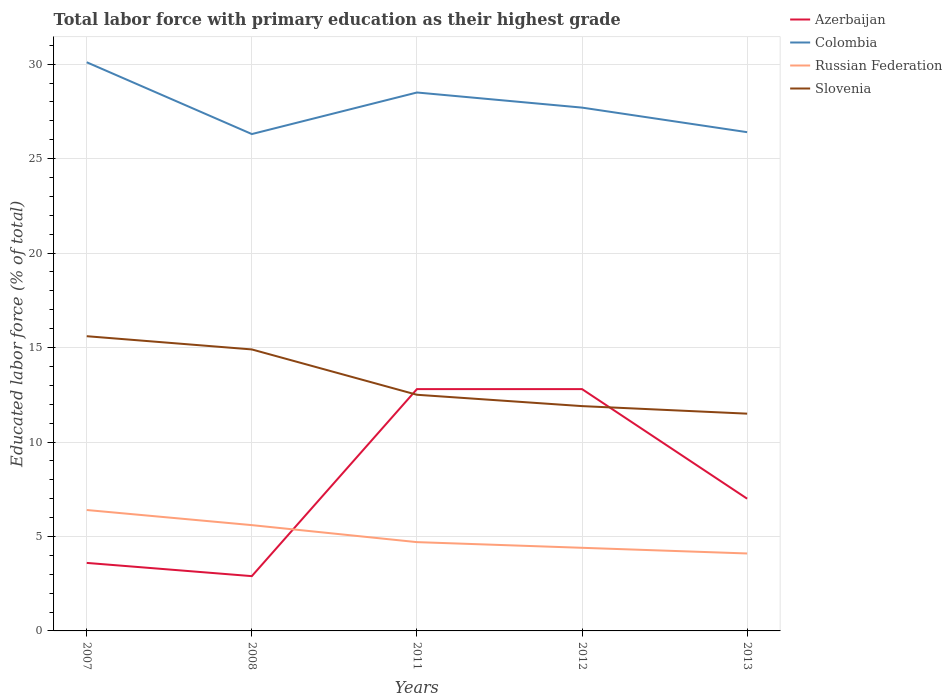Is the number of lines equal to the number of legend labels?
Ensure brevity in your answer.  Yes. Across all years, what is the maximum percentage of total labor force with primary education in Azerbaijan?
Provide a succinct answer. 2.9. In which year was the percentage of total labor force with primary education in Slovenia maximum?
Ensure brevity in your answer.  2013. What is the total percentage of total labor force with primary education in Russian Federation in the graph?
Provide a succinct answer. 1.5. What is the difference between the highest and the second highest percentage of total labor force with primary education in Slovenia?
Your answer should be compact. 4.1. Is the percentage of total labor force with primary education in Russian Federation strictly greater than the percentage of total labor force with primary education in Slovenia over the years?
Give a very brief answer. Yes. Does the graph contain any zero values?
Your response must be concise. No. Where does the legend appear in the graph?
Make the answer very short. Top right. How many legend labels are there?
Your response must be concise. 4. What is the title of the graph?
Provide a short and direct response. Total labor force with primary education as their highest grade. What is the label or title of the X-axis?
Your response must be concise. Years. What is the label or title of the Y-axis?
Provide a succinct answer. Educated labor force (% of total). What is the Educated labor force (% of total) in Azerbaijan in 2007?
Your answer should be compact. 3.6. What is the Educated labor force (% of total) of Colombia in 2007?
Provide a short and direct response. 30.1. What is the Educated labor force (% of total) in Russian Federation in 2007?
Keep it short and to the point. 6.4. What is the Educated labor force (% of total) in Slovenia in 2007?
Offer a terse response. 15.6. What is the Educated labor force (% of total) of Azerbaijan in 2008?
Make the answer very short. 2.9. What is the Educated labor force (% of total) in Colombia in 2008?
Your answer should be very brief. 26.3. What is the Educated labor force (% of total) of Russian Federation in 2008?
Make the answer very short. 5.6. What is the Educated labor force (% of total) in Slovenia in 2008?
Give a very brief answer. 14.9. What is the Educated labor force (% of total) of Azerbaijan in 2011?
Provide a succinct answer. 12.8. What is the Educated labor force (% of total) in Colombia in 2011?
Offer a very short reply. 28.5. What is the Educated labor force (% of total) of Russian Federation in 2011?
Ensure brevity in your answer.  4.7. What is the Educated labor force (% of total) of Slovenia in 2011?
Your answer should be very brief. 12.5. What is the Educated labor force (% of total) in Azerbaijan in 2012?
Give a very brief answer. 12.8. What is the Educated labor force (% of total) of Colombia in 2012?
Your answer should be very brief. 27.7. What is the Educated labor force (% of total) of Russian Federation in 2012?
Make the answer very short. 4.4. What is the Educated labor force (% of total) in Slovenia in 2012?
Give a very brief answer. 11.9. What is the Educated labor force (% of total) of Azerbaijan in 2013?
Provide a succinct answer. 7. What is the Educated labor force (% of total) in Colombia in 2013?
Offer a very short reply. 26.4. What is the Educated labor force (% of total) of Russian Federation in 2013?
Provide a succinct answer. 4.1. What is the Educated labor force (% of total) in Slovenia in 2013?
Provide a succinct answer. 11.5. Across all years, what is the maximum Educated labor force (% of total) in Azerbaijan?
Your answer should be compact. 12.8. Across all years, what is the maximum Educated labor force (% of total) of Colombia?
Your response must be concise. 30.1. Across all years, what is the maximum Educated labor force (% of total) of Russian Federation?
Offer a terse response. 6.4. Across all years, what is the maximum Educated labor force (% of total) of Slovenia?
Offer a very short reply. 15.6. Across all years, what is the minimum Educated labor force (% of total) in Azerbaijan?
Your answer should be very brief. 2.9. Across all years, what is the minimum Educated labor force (% of total) of Colombia?
Your answer should be very brief. 26.3. Across all years, what is the minimum Educated labor force (% of total) of Russian Federation?
Provide a succinct answer. 4.1. What is the total Educated labor force (% of total) of Azerbaijan in the graph?
Give a very brief answer. 39.1. What is the total Educated labor force (% of total) of Colombia in the graph?
Provide a short and direct response. 139. What is the total Educated labor force (% of total) of Russian Federation in the graph?
Keep it short and to the point. 25.2. What is the total Educated labor force (% of total) of Slovenia in the graph?
Your answer should be compact. 66.4. What is the difference between the Educated labor force (% of total) in Azerbaijan in 2007 and that in 2008?
Offer a very short reply. 0.7. What is the difference between the Educated labor force (% of total) of Colombia in 2007 and that in 2008?
Your response must be concise. 3.8. What is the difference between the Educated labor force (% of total) in Azerbaijan in 2007 and that in 2011?
Your answer should be very brief. -9.2. What is the difference between the Educated labor force (% of total) in Colombia in 2007 and that in 2012?
Give a very brief answer. 2.4. What is the difference between the Educated labor force (% of total) of Azerbaijan in 2007 and that in 2013?
Offer a terse response. -3.4. What is the difference between the Educated labor force (% of total) of Russian Federation in 2007 and that in 2013?
Keep it short and to the point. 2.3. What is the difference between the Educated labor force (% of total) in Azerbaijan in 2008 and that in 2011?
Give a very brief answer. -9.9. What is the difference between the Educated labor force (% of total) of Russian Federation in 2008 and that in 2011?
Give a very brief answer. 0.9. What is the difference between the Educated labor force (% of total) in Slovenia in 2008 and that in 2011?
Provide a short and direct response. 2.4. What is the difference between the Educated labor force (% of total) of Azerbaijan in 2008 and that in 2012?
Provide a succinct answer. -9.9. What is the difference between the Educated labor force (% of total) of Russian Federation in 2008 and that in 2012?
Provide a short and direct response. 1.2. What is the difference between the Educated labor force (% of total) of Slovenia in 2008 and that in 2012?
Provide a succinct answer. 3. What is the difference between the Educated labor force (% of total) in Azerbaijan in 2008 and that in 2013?
Your answer should be compact. -4.1. What is the difference between the Educated labor force (% of total) of Colombia in 2008 and that in 2013?
Your answer should be compact. -0.1. What is the difference between the Educated labor force (% of total) of Azerbaijan in 2011 and that in 2012?
Ensure brevity in your answer.  0. What is the difference between the Educated labor force (% of total) in Colombia in 2011 and that in 2013?
Your response must be concise. 2.1. What is the difference between the Educated labor force (% of total) of Russian Federation in 2011 and that in 2013?
Provide a succinct answer. 0.6. What is the difference between the Educated labor force (% of total) of Slovenia in 2011 and that in 2013?
Provide a succinct answer. 1. What is the difference between the Educated labor force (% of total) in Azerbaijan in 2012 and that in 2013?
Your answer should be compact. 5.8. What is the difference between the Educated labor force (% of total) of Colombia in 2012 and that in 2013?
Your answer should be very brief. 1.3. What is the difference between the Educated labor force (% of total) in Azerbaijan in 2007 and the Educated labor force (% of total) in Colombia in 2008?
Provide a short and direct response. -22.7. What is the difference between the Educated labor force (% of total) in Azerbaijan in 2007 and the Educated labor force (% of total) in Slovenia in 2008?
Your response must be concise. -11.3. What is the difference between the Educated labor force (% of total) of Colombia in 2007 and the Educated labor force (% of total) of Slovenia in 2008?
Your response must be concise. 15.2. What is the difference between the Educated labor force (% of total) in Azerbaijan in 2007 and the Educated labor force (% of total) in Colombia in 2011?
Keep it short and to the point. -24.9. What is the difference between the Educated labor force (% of total) in Azerbaijan in 2007 and the Educated labor force (% of total) in Russian Federation in 2011?
Give a very brief answer. -1.1. What is the difference between the Educated labor force (% of total) in Colombia in 2007 and the Educated labor force (% of total) in Russian Federation in 2011?
Provide a succinct answer. 25.4. What is the difference between the Educated labor force (% of total) of Colombia in 2007 and the Educated labor force (% of total) of Slovenia in 2011?
Provide a short and direct response. 17.6. What is the difference between the Educated labor force (% of total) in Azerbaijan in 2007 and the Educated labor force (% of total) in Colombia in 2012?
Provide a short and direct response. -24.1. What is the difference between the Educated labor force (% of total) in Azerbaijan in 2007 and the Educated labor force (% of total) in Russian Federation in 2012?
Offer a very short reply. -0.8. What is the difference between the Educated labor force (% of total) in Colombia in 2007 and the Educated labor force (% of total) in Russian Federation in 2012?
Provide a short and direct response. 25.7. What is the difference between the Educated labor force (% of total) of Colombia in 2007 and the Educated labor force (% of total) of Slovenia in 2012?
Your answer should be very brief. 18.2. What is the difference between the Educated labor force (% of total) in Azerbaijan in 2007 and the Educated labor force (% of total) in Colombia in 2013?
Provide a short and direct response. -22.8. What is the difference between the Educated labor force (% of total) of Azerbaijan in 2007 and the Educated labor force (% of total) of Russian Federation in 2013?
Provide a short and direct response. -0.5. What is the difference between the Educated labor force (% of total) in Azerbaijan in 2007 and the Educated labor force (% of total) in Slovenia in 2013?
Keep it short and to the point. -7.9. What is the difference between the Educated labor force (% of total) in Colombia in 2007 and the Educated labor force (% of total) in Slovenia in 2013?
Keep it short and to the point. 18.6. What is the difference between the Educated labor force (% of total) of Russian Federation in 2007 and the Educated labor force (% of total) of Slovenia in 2013?
Provide a short and direct response. -5.1. What is the difference between the Educated labor force (% of total) of Azerbaijan in 2008 and the Educated labor force (% of total) of Colombia in 2011?
Keep it short and to the point. -25.6. What is the difference between the Educated labor force (% of total) in Azerbaijan in 2008 and the Educated labor force (% of total) in Slovenia in 2011?
Keep it short and to the point. -9.6. What is the difference between the Educated labor force (% of total) of Colombia in 2008 and the Educated labor force (% of total) of Russian Federation in 2011?
Offer a very short reply. 21.6. What is the difference between the Educated labor force (% of total) in Azerbaijan in 2008 and the Educated labor force (% of total) in Colombia in 2012?
Offer a terse response. -24.8. What is the difference between the Educated labor force (% of total) in Colombia in 2008 and the Educated labor force (% of total) in Russian Federation in 2012?
Offer a terse response. 21.9. What is the difference between the Educated labor force (% of total) of Russian Federation in 2008 and the Educated labor force (% of total) of Slovenia in 2012?
Ensure brevity in your answer.  -6.3. What is the difference between the Educated labor force (% of total) of Azerbaijan in 2008 and the Educated labor force (% of total) of Colombia in 2013?
Ensure brevity in your answer.  -23.5. What is the difference between the Educated labor force (% of total) of Azerbaijan in 2008 and the Educated labor force (% of total) of Russian Federation in 2013?
Provide a succinct answer. -1.2. What is the difference between the Educated labor force (% of total) in Azerbaijan in 2008 and the Educated labor force (% of total) in Slovenia in 2013?
Keep it short and to the point. -8.6. What is the difference between the Educated labor force (% of total) in Colombia in 2008 and the Educated labor force (% of total) in Russian Federation in 2013?
Make the answer very short. 22.2. What is the difference between the Educated labor force (% of total) of Colombia in 2008 and the Educated labor force (% of total) of Slovenia in 2013?
Your answer should be very brief. 14.8. What is the difference between the Educated labor force (% of total) of Azerbaijan in 2011 and the Educated labor force (% of total) of Colombia in 2012?
Provide a succinct answer. -14.9. What is the difference between the Educated labor force (% of total) of Colombia in 2011 and the Educated labor force (% of total) of Russian Federation in 2012?
Ensure brevity in your answer.  24.1. What is the difference between the Educated labor force (% of total) of Azerbaijan in 2011 and the Educated labor force (% of total) of Slovenia in 2013?
Ensure brevity in your answer.  1.3. What is the difference between the Educated labor force (% of total) in Colombia in 2011 and the Educated labor force (% of total) in Russian Federation in 2013?
Give a very brief answer. 24.4. What is the difference between the Educated labor force (% of total) in Azerbaijan in 2012 and the Educated labor force (% of total) in Colombia in 2013?
Offer a terse response. -13.6. What is the difference between the Educated labor force (% of total) in Azerbaijan in 2012 and the Educated labor force (% of total) in Slovenia in 2013?
Your answer should be compact. 1.3. What is the difference between the Educated labor force (% of total) in Colombia in 2012 and the Educated labor force (% of total) in Russian Federation in 2013?
Provide a short and direct response. 23.6. What is the average Educated labor force (% of total) of Azerbaijan per year?
Provide a short and direct response. 7.82. What is the average Educated labor force (% of total) in Colombia per year?
Provide a short and direct response. 27.8. What is the average Educated labor force (% of total) in Russian Federation per year?
Offer a very short reply. 5.04. What is the average Educated labor force (% of total) in Slovenia per year?
Your answer should be very brief. 13.28. In the year 2007, what is the difference between the Educated labor force (% of total) in Azerbaijan and Educated labor force (% of total) in Colombia?
Ensure brevity in your answer.  -26.5. In the year 2007, what is the difference between the Educated labor force (% of total) of Azerbaijan and Educated labor force (% of total) of Russian Federation?
Provide a succinct answer. -2.8. In the year 2007, what is the difference between the Educated labor force (% of total) of Colombia and Educated labor force (% of total) of Russian Federation?
Offer a very short reply. 23.7. In the year 2007, what is the difference between the Educated labor force (% of total) of Colombia and Educated labor force (% of total) of Slovenia?
Offer a terse response. 14.5. In the year 2007, what is the difference between the Educated labor force (% of total) of Russian Federation and Educated labor force (% of total) of Slovenia?
Keep it short and to the point. -9.2. In the year 2008, what is the difference between the Educated labor force (% of total) of Azerbaijan and Educated labor force (% of total) of Colombia?
Provide a short and direct response. -23.4. In the year 2008, what is the difference between the Educated labor force (% of total) in Colombia and Educated labor force (% of total) in Russian Federation?
Keep it short and to the point. 20.7. In the year 2011, what is the difference between the Educated labor force (% of total) in Azerbaijan and Educated labor force (% of total) in Colombia?
Offer a very short reply. -15.7. In the year 2011, what is the difference between the Educated labor force (% of total) in Azerbaijan and Educated labor force (% of total) in Russian Federation?
Provide a succinct answer. 8.1. In the year 2011, what is the difference between the Educated labor force (% of total) of Azerbaijan and Educated labor force (% of total) of Slovenia?
Provide a short and direct response. 0.3. In the year 2011, what is the difference between the Educated labor force (% of total) in Colombia and Educated labor force (% of total) in Russian Federation?
Make the answer very short. 23.8. In the year 2011, what is the difference between the Educated labor force (% of total) of Colombia and Educated labor force (% of total) of Slovenia?
Keep it short and to the point. 16. In the year 2011, what is the difference between the Educated labor force (% of total) of Russian Federation and Educated labor force (% of total) of Slovenia?
Your answer should be very brief. -7.8. In the year 2012, what is the difference between the Educated labor force (% of total) in Azerbaijan and Educated labor force (% of total) in Colombia?
Your answer should be compact. -14.9. In the year 2012, what is the difference between the Educated labor force (% of total) of Azerbaijan and Educated labor force (% of total) of Russian Federation?
Ensure brevity in your answer.  8.4. In the year 2012, what is the difference between the Educated labor force (% of total) of Colombia and Educated labor force (% of total) of Russian Federation?
Ensure brevity in your answer.  23.3. In the year 2012, what is the difference between the Educated labor force (% of total) in Colombia and Educated labor force (% of total) in Slovenia?
Offer a terse response. 15.8. In the year 2013, what is the difference between the Educated labor force (% of total) of Azerbaijan and Educated labor force (% of total) of Colombia?
Offer a terse response. -19.4. In the year 2013, what is the difference between the Educated labor force (% of total) of Azerbaijan and Educated labor force (% of total) of Slovenia?
Provide a short and direct response. -4.5. In the year 2013, what is the difference between the Educated labor force (% of total) of Colombia and Educated labor force (% of total) of Russian Federation?
Offer a very short reply. 22.3. In the year 2013, what is the difference between the Educated labor force (% of total) in Colombia and Educated labor force (% of total) in Slovenia?
Your answer should be very brief. 14.9. In the year 2013, what is the difference between the Educated labor force (% of total) in Russian Federation and Educated labor force (% of total) in Slovenia?
Ensure brevity in your answer.  -7.4. What is the ratio of the Educated labor force (% of total) of Azerbaijan in 2007 to that in 2008?
Your answer should be compact. 1.24. What is the ratio of the Educated labor force (% of total) of Colombia in 2007 to that in 2008?
Offer a very short reply. 1.14. What is the ratio of the Educated labor force (% of total) in Russian Federation in 2007 to that in 2008?
Provide a short and direct response. 1.14. What is the ratio of the Educated labor force (% of total) of Slovenia in 2007 to that in 2008?
Your response must be concise. 1.05. What is the ratio of the Educated labor force (% of total) of Azerbaijan in 2007 to that in 2011?
Ensure brevity in your answer.  0.28. What is the ratio of the Educated labor force (% of total) in Colombia in 2007 to that in 2011?
Give a very brief answer. 1.06. What is the ratio of the Educated labor force (% of total) in Russian Federation in 2007 to that in 2011?
Provide a succinct answer. 1.36. What is the ratio of the Educated labor force (% of total) in Slovenia in 2007 to that in 2011?
Your answer should be compact. 1.25. What is the ratio of the Educated labor force (% of total) of Azerbaijan in 2007 to that in 2012?
Offer a very short reply. 0.28. What is the ratio of the Educated labor force (% of total) in Colombia in 2007 to that in 2012?
Keep it short and to the point. 1.09. What is the ratio of the Educated labor force (% of total) in Russian Federation in 2007 to that in 2012?
Offer a terse response. 1.45. What is the ratio of the Educated labor force (% of total) in Slovenia in 2007 to that in 2012?
Provide a short and direct response. 1.31. What is the ratio of the Educated labor force (% of total) of Azerbaijan in 2007 to that in 2013?
Give a very brief answer. 0.51. What is the ratio of the Educated labor force (% of total) of Colombia in 2007 to that in 2013?
Provide a short and direct response. 1.14. What is the ratio of the Educated labor force (% of total) of Russian Federation in 2007 to that in 2013?
Make the answer very short. 1.56. What is the ratio of the Educated labor force (% of total) in Slovenia in 2007 to that in 2013?
Offer a very short reply. 1.36. What is the ratio of the Educated labor force (% of total) in Azerbaijan in 2008 to that in 2011?
Your response must be concise. 0.23. What is the ratio of the Educated labor force (% of total) in Colombia in 2008 to that in 2011?
Keep it short and to the point. 0.92. What is the ratio of the Educated labor force (% of total) of Russian Federation in 2008 to that in 2011?
Provide a succinct answer. 1.19. What is the ratio of the Educated labor force (% of total) in Slovenia in 2008 to that in 2011?
Provide a succinct answer. 1.19. What is the ratio of the Educated labor force (% of total) in Azerbaijan in 2008 to that in 2012?
Ensure brevity in your answer.  0.23. What is the ratio of the Educated labor force (% of total) of Colombia in 2008 to that in 2012?
Offer a terse response. 0.95. What is the ratio of the Educated labor force (% of total) of Russian Federation in 2008 to that in 2012?
Keep it short and to the point. 1.27. What is the ratio of the Educated labor force (% of total) of Slovenia in 2008 to that in 2012?
Ensure brevity in your answer.  1.25. What is the ratio of the Educated labor force (% of total) of Azerbaijan in 2008 to that in 2013?
Keep it short and to the point. 0.41. What is the ratio of the Educated labor force (% of total) in Russian Federation in 2008 to that in 2013?
Offer a terse response. 1.37. What is the ratio of the Educated labor force (% of total) in Slovenia in 2008 to that in 2013?
Offer a terse response. 1.3. What is the ratio of the Educated labor force (% of total) of Azerbaijan in 2011 to that in 2012?
Your answer should be very brief. 1. What is the ratio of the Educated labor force (% of total) of Colombia in 2011 to that in 2012?
Your answer should be very brief. 1.03. What is the ratio of the Educated labor force (% of total) of Russian Federation in 2011 to that in 2012?
Offer a very short reply. 1.07. What is the ratio of the Educated labor force (% of total) of Slovenia in 2011 to that in 2012?
Offer a very short reply. 1.05. What is the ratio of the Educated labor force (% of total) in Azerbaijan in 2011 to that in 2013?
Give a very brief answer. 1.83. What is the ratio of the Educated labor force (% of total) in Colombia in 2011 to that in 2013?
Provide a succinct answer. 1.08. What is the ratio of the Educated labor force (% of total) in Russian Federation in 2011 to that in 2013?
Your answer should be very brief. 1.15. What is the ratio of the Educated labor force (% of total) of Slovenia in 2011 to that in 2013?
Provide a short and direct response. 1.09. What is the ratio of the Educated labor force (% of total) in Azerbaijan in 2012 to that in 2013?
Offer a terse response. 1.83. What is the ratio of the Educated labor force (% of total) of Colombia in 2012 to that in 2013?
Make the answer very short. 1.05. What is the ratio of the Educated labor force (% of total) in Russian Federation in 2012 to that in 2013?
Your answer should be compact. 1.07. What is the ratio of the Educated labor force (% of total) of Slovenia in 2012 to that in 2013?
Your response must be concise. 1.03. What is the difference between the highest and the second highest Educated labor force (% of total) of Russian Federation?
Provide a succinct answer. 0.8. What is the difference between the highest and the second highest Educated labor force (% of total) in Slovenia?
Your response must be concise. 0.7. 